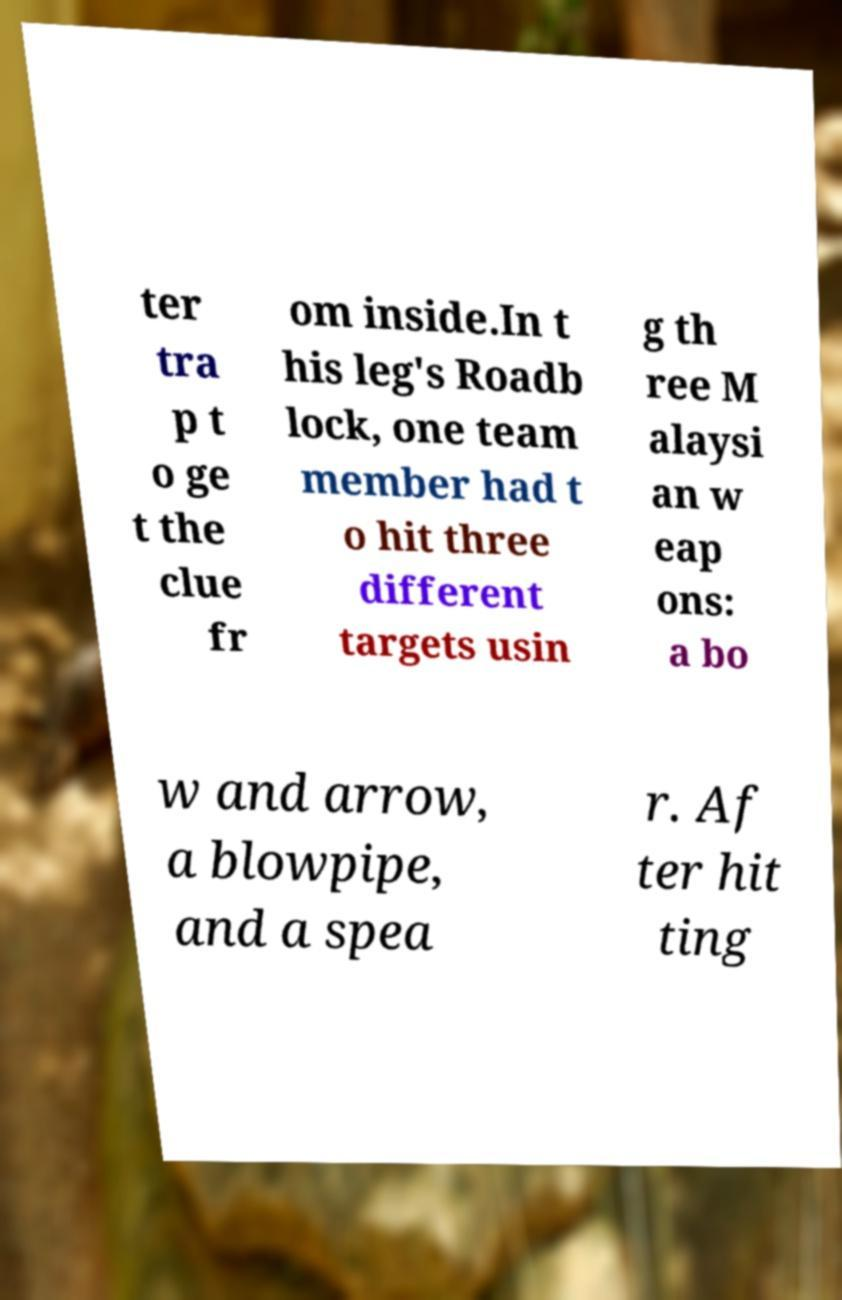What messages or text are displayed in this image? I need them in a readable, typed format. ter tra p t o ge t the clue fr om inside.In t his leg's Roadb lock, one team member had t o hit three different targets usin g th ree M alaysi an w eap ons: a bo w and arrow, a blowpipe, and a spea r. Af ter hit ting 